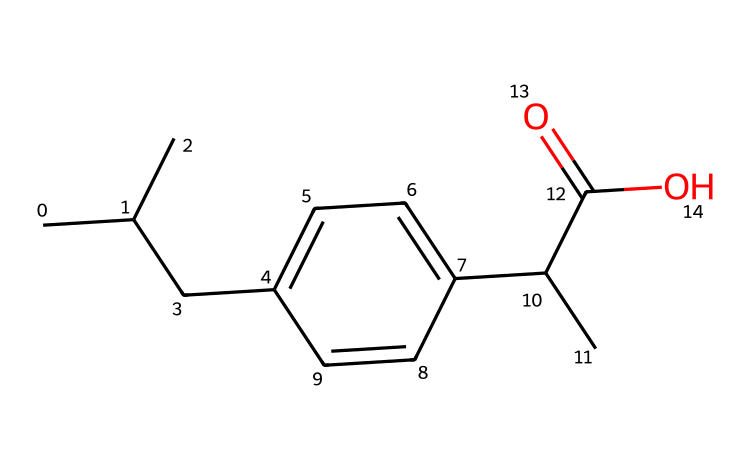What is the molecular formula of this chemical? To determine the molecular formula, we need to count the number of each type of atom displayed in the SMILES. The structure has 15 carbons (C), 24 hydrogens (H), and 2 oxygens (O). Thus, the molecular formula is derived by combining these counts.
Answer: C15H24O2 How many rings are present in this chemical? By analyzing the structure represented by the SMILES, there are no cyclic structures indicated, as all atoms connect in a linear and branched formation. The absence of numbers or symbols indicating rings confirms that this chemical does not contain any rings.
Answer: 0 Is this chemical likely to be a solid or liquid at room temperature? Given the structural characteristics typical of similar molecules in the same class (like fatty acids), and considering the carbon chain length and presence of functional groups, it can be inferred that this chemical is likely a liquid at room temperature due to its lower melting point.
Answer: liquid What functional groups are present in this chemical? Looking at the structure, it shows the presence of a carboxylic acid group (C(=O)O), which is identified by the 'C(=O)' part, and a branched alkyl chain. This indicates that the carboxylic acid functional group is a key feature of this chemical's structure.
Answer: carboxylic acid What type of drug is this chemical classified as? Given its structural features, particularly the presence of the carboxylic acid group and common applications, this chemical is classified as a non-steroidal anti-inflammatory drug (NSAID), frequently used for its analgesic and anti-inflammatory properties.
Answer: NSAID What is the significance of the branched carbon chain in this chemical? The branched carbon chain impacts the solubility and absorption of the drug in the body. In many cases, branched chains increase bioavailability, allowing the drug to be more effective. It also influences the melting point and stability of the substance.
Answer: increases bioavailability 